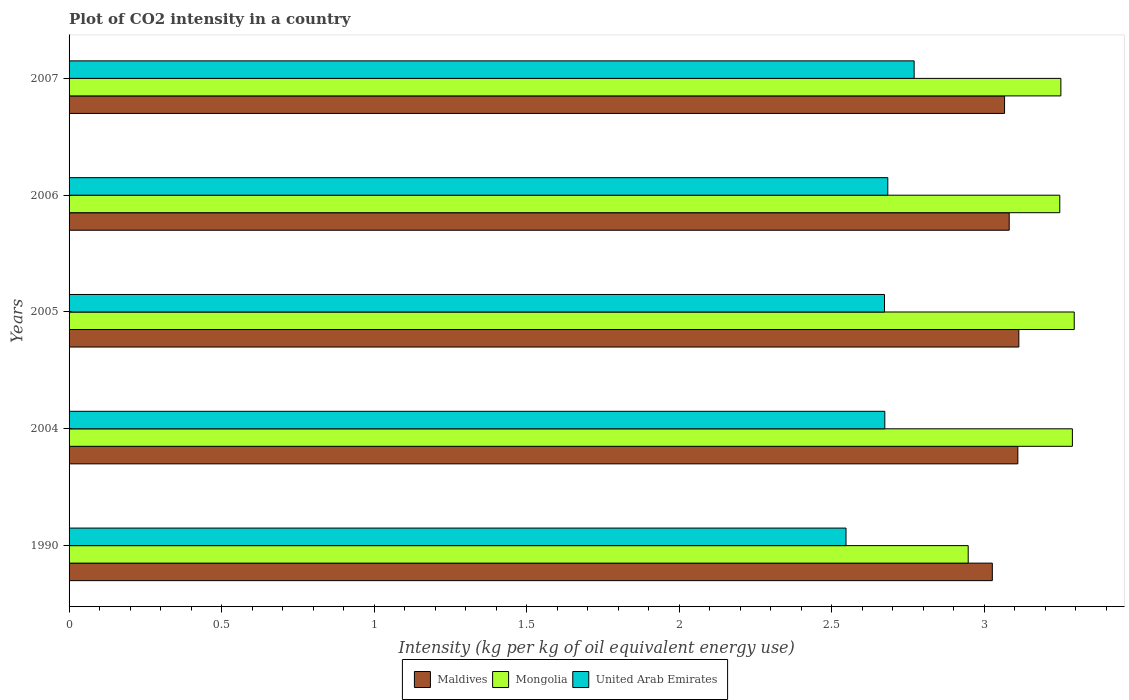Are the number of bars per tick equal to the number of legend labels?
Keep it short and to the point. Yes. Are the number of bars on each tick of the Y-axis equal?
Make the answer very short. Yes. How many bars are there on the 4th tick from the top?
Your answer should be very brief. 3. How many bars are there on the 1st tick from the bottom?
Provide a short and direct response. 3. What is the label of the 2nd group of bars from the top?
Your response must be concise. 2006. What is the CO2 intensity in in Mongolia in 2007?
Keep it short and to the point. 3.25. Across all years, what is the maximum CO2 intensity in in Maldives?
Provide a short and direct response. 3.11. Across all years, what is the minimum CO2 intensity in in Mongolia?
Give a very brief answer. 2.95. What is the total CO2 intensity in in Mongolia in the graph?
Give a very brief answer. 16.03. What is the difference between the CO2 intensity in in Mongolia in 2004 and that in 2007?
Provide a short and direct response. 0.04. What is the difference between the CO2 intensity in in Mongolia in 1990 and the CO2 intensity in in United Arab Emirates in 2006?
Offer a terse response. 0.26. What is the average CO2 intensity in in Mongolia per year?
Keep it short and to the point. 3.21. In the year 2005, what is the difference between the CO2 intensity in in Mongolia and CO2 intensity in in Maldives?
Provide a short and direct response. 0.18. In how many years, is the CO2 intensity in in Mongolia greater than 0.30000000000000004 kg?
Ensure brevity in your answer.  5. What is the ratio of the CO2 intensity in in United Arab Emirates in 1990 to that in 2005?
Offer a terse response. 0.95. Is the CO2 intensity in in Mongolia in 2004 less than that in 2005?
Provide a short and direct response. Yes. What is the difference between the highest and the second highest CO2 intensity in in Mongolia?
Make the answer very short. 0.01. What is the difference between the highest and the lowest CO2 intensity in in United Arab Emirates?
Give a very brief answer. 0.22. In how many years, is the CO2 intensity in in Maldives greater than the average CO2 intensity in in Maldives taken over all years?
Offer a very short reply. 3. What does the 2nd bar from the top in 2004 represents?
Give a very brief answer. Mongolia. What does the 2nd bar from the bottom in 1990 represents?
Give a very brief answer. Mongolia. How many bars are there?
Give a very brief answer. 15. What is the difference between two consecutive major ticks on the X-axis?
Provide a succinct answer. 0.5. Does the graph contain any zero values?
Offer a very short reply. No. Where does the legend appear in the graph?
Offer a very short reply. Bottom center. How are the legend labels stacked?
Provide a short and direct response. Horizontal. What is the title of the graph?
Provide a short and direct response. Plot of CO2 intensity in a country. Does "Angola" appear as one of the legend labels in the graph?
Your answer should be very brief. No. What is the label or title of the X-axis?
Provide a short and direct response. Intensity (kg per kg of oil equivalent energy use). What is the Intensity (kg per kg of oil equivalent energy use) in Maldives in 1990?
Give a very brief answer. 3.03. What is the Intensity (kg per kg of oil equivalent energy use) of Mongolia in 1990?
Ensure brevity in your answer.  2.95. What is the Intensity (kg per kg of oil equivalent energy use) in United Arab Emirates in 1990?
Provide a succinct answer. 2.55. What is the Intensity (kg per kg of oil equivalent energy use) in Maldives in 2004?
Give a very brief answer. 3.11. What is the Intensity (kg per kg of oil equivalent energy use) of Mongolia in 2004?
Make the answer very short. 3.29. What is the Intensity (kg per kg of oil equivalent energy use) in United Arab Emirates in 2004?
Offer a very short reply. 2.67. What is the Intensity (kg per kg of oil equivalent energy use) in Maldives in 2005?
Offer a very short reply. 3.11. What is the Intensity (kg per kg of oil equivalent energy use) of Mongolia in 2005?
Keep it short and to the point. 3.29. What is the Intensity (kg per kg of oil equivalent energy use) of United Arab Emirates in 2005?
Make the answer very short. 2.67. What is the Intensity (kg per kg of oil equivalent energy use) of Maldives in 2006?
Give a very brief answer. 3.08. What is the Intensity (kg per kg of oil equivalent energy use) in Mongolia in 2006?
Your answer should be very brief. 3.25. What is the Intensity (kg per kg of oil equivalent energy use) in United Arab Emirates in 2006?
Your answer should be very brief. 2.68. What is the Intensity (kg per kg of oil equivalent energy use) in Maldives in 2007?
Keep it short and to the point. 3.07. What is the Intensity (kg per kg of oil equivalent energy use) of Mongolia in 2007?
Give a very brief answer. 3.25. What is the Intensity (kg per kg of oil equivalent energy use) in United Arab Emirates in 2007?
Your answer should be very brief. 2.77. Across all years, what is the maximum Intensity (kg per kg of oil equivalent energy use) of Maldives?
Your answer should be very brief. 3.11. Across all years, what is the maximum Intensity (kg per kg of oil equivalent energy use) of Mongolia?
Provide a short and direct response. 3.29. Across all years, what is the maximum Intensity (kg per kg of oil equivalent energy use) of United Arab Emirates?
Your answer should be very brief. 2.77. Across all years, what is the minimum Intensity (kg per kg of oil equivalent energy use) of Maldives?
Provide a succinct answer. 3.03. Across all years, what is the minimum Intensity (kg per kg of oil equivalent energy use) of Mongolia?
Ensure brevity in your answer.  2.95. Across all years, what is the minimum Intensity (kg per kg of oil equivalent energy use) of United Arab Emirates?
Provide a succinct answer. 2.55. What is the total Intensity (kg per kg of oil equivalent energy use) of Maldives in the graph?
Provide a short and direct response. 15.4. What is the total Intensity (kg per kg of oil equivalent energy use) of Mongolia in the graph?
Your answer should be very brief. 16.03. What is the total Intensity (kg per kg of oil equivalent energy use) of United Arab Emirates in the graph?
Ensure brevity in your answer.  13.35. What is the difference between the Intensity (kg per kg of oil equivalent energy use) in Maldives in 1990 and that in 2004?
Your response must be concise. -0.08. What is the difference between the Intensity (kg per kg of oil equivalent energy use) of Mongolia in 1990 and that in 2004?
Keep it short and to the point. -0.34. What is the difference between the Intensity (kg per kg of oil equivalent energy use) of United Arab Emirates in 1990 and that in 2004?
Ensure brevity in your answer.  -0.13. What is the difference between the Intensity (kg per kg of oil equivalent energy use) in Maldives in 1990 and that in 2005?
Your answer should be very brief. -0.09. What is the difference between the Intensity (kg per kg of oil equivalent energy use) in Mongolia in 1990 and that in 2005?
Provide a short and direct response. -0.35. What is the difference between the Intensity (kg per kg of oil equivalent energy use) of United Arab Emirates in 1990 and that in 2005?
Offer a terse response. -0.13. What is the difference between the Intensity (kg per kg of oil equivalent energy use) in Maldives in 1990 and that in 2006?
Ensure brevity in your answer.  -0.06. What is the difference between the Intensity (kg per kg of oil equivalent energy use) of Mongolia in 1990 and that in 2006?
Your response must be concise. -0.3. What is the difference between the Intensity (kg per kg of oil equivalent energy use) in United Arab Emirates in 1990 and that in 2006?
Your response must be concise. -0.14. What is the difference between the Intensity (kg per kg of oil equivalent energy use) of Maldives in 1990 and that in 2007?
Offer a very short reply. -0.04. What is the difference between the Intensity (kg per kg of oil equivalent energy use) in Mongolia in 1990 and that in 2007?
Offer a very short reply. -0.3. What is the difference between the Intensity (kg per kg of oil equivalent energy use) of United Arab Emirates in 1990 and that in 2007?
Your answer should be compact. -0.22. What is the difference between the Intensity (kg per kg of oil equivalent energy use) of Maldives in 2004 and that in 2005?
Provide a short and direct response. -0. What is the difference between the Intensity (kg per kg of oil equivalent energy use) in Mongolia in 2004 and that in 2005?
Make the answer very short. -0.01. What is the difference between the Intensity (kg per kg of oil equivalent energy use) in Maldives in 2004 and that in 2006?
Make the answer very short. 0.03. What is the difference between the Intensity (kg per kg of oil equivalent energy use) of Mongolia in 2004 and that in 2006?
Offer a very short reply. 0.04. What is the difference between the Intensity (kg per kg of oil equivalent energy use) of United Arab Emirates in 2004 and that in 2006?
Ensure brevity in your answer.  -0.01. What is the difference between the Intensity (kg per kg of oil equivalent energy use) of Maldives in 2004 and that in 2007?
Make the answer very short. 0.04. What is the difference between the Intensity (kg per kg of oil equivalent energy use) of Mongolia in 2004 and that in 2007?
Offer a very short reply. 0.04. What is the difference between the Intensity (kg per kg of oil equivalent energy use) in United Arab Emirates in 2004 and that in 2007?
Your answer should be compact. -0.1. What is the difference between the Intensity (kg per kg of oil equivalent energy use) of Maldives in 2005 and that in 2006?
Provide a short and direct response. 0.03. What is the difference between the Intensity (kg per kg of oil equivalent energy use) in Mongolia in 2005 and that in 2006?
Keep it short and to the point. 0.05. What is the difference between the Intensity (kg per kg of oil equivalent energy use) in United Arab Emirates in 2005 and that in 2006?
Provide a short and direct response. -0.01. What is the difference between the Intensity (kg per kg of oil equivalent energy use) of Maldives in 2005 and that in 2007?
Give a very brief answer. 0.05. What is the difference between the Intensity (kg per kg of oil equivalent energy use) in Mongolia in 2005 and that in 2007?
Your answer should be compact. 0.04. What is the difference between the Intensity (kg per kg of oil equivalent energy use) in United Arab Emirates in 2005 and that in 2007?
Your answer should be very brief. -0.1. What is the difference between the Intensity (kg per kg of oil equivalent energy use) of Maldives in 2006 and that in 2007?
Make the answer very short. 0.02. What is the difference between the Intensity (kg per kg of oil equivalent energy use) of Mongolia in 2006 and that in 2007?
Offer a terse response. -0. What is the difference between the Intensity (kg per kg of oil equivalent energy use) of United Arab Emirates in 2006 and that in 2007?
Offer a very short reply. -0.09. What is the difference between the Intensity (kg per kg of oil equivalent energy use) in Maldives in 1990 and the Intensity (kg per kg of oil equivalent energy use) in Mongolia in 2004?
Offer a terse response. -0.26. What is the difference between the Intensity (kg per kg of oil equivalent energy use) of Maldives in 1990 and the Intensity (kg per kg of oil equivalent energy use) of United Arab Emirates in 2004?
Your response must be concise. 0.35. What is the difference between the Intensity (kg per kg of oil equivalent energy use) in Mongolia in 1990 and the Intensity (kg per kg of oil equivalent energy use) in United Arab Emirates in 2004?
Your answer should be very brief. 0.27. What is the difference between the Intensity (kg per kg of oil equivalent energy use) of Maldives in 1990 and the Intensity (kg per kg of oil equivalent energy use) of Mongolia in 2005?
Your answer should be very brief. -0.27. What is the difference between the Intensity (kg per kg of oil equivalent energy use) in Maldives in 1990 and the Intensity (kg per kg of oil equivalent energy use) in United Arab Emirates in 2005?
Offer a terse response. 0.35. What is the difference between the Intensity (kg per kg of oil equivalent energy use) of Mongolia in 1990 and the Intensity (kg per kg of oil equivalent energy use) of United Arab Emirates in 2005?
Offer a terse response. 0.27. What is the difference between the Intensity (kg per kg of oil equivalent energy use) of Maldives in 1990 and the Intensity (kg per kg of oil equivalent energy use) of Mongolia in 2006?
Your response must be concise. -0.22. What is the difference between the Intensity (kg per kg of oil equivalent energy use) in Maldives in 1990 and the Intensity (kg per kg of oil equivalent energy use) in United Arab Emirates in 2006?
Your answer should be compact. 0.34. What is the difference between the Intensity (kg per kg of oil equivalent energy use) of Mongolia in 1990 and the Intensity (kg per kg of oil equivalent energy use) of United Arab Emirates in 2006?
Your response must be concise. 0.26. What is the difference between the Intensity (kg per kg of oil equivalent energy use) in Maldives in 1990 and the Intensity (kg per kg of oil equivalent energy use) in Mongolia in 2007?
Offer a very short reply. -0.22. What is the difference between the Intensity (kg per kg of oil equivalent energy use) in Maldives in 1990 and the Intensity (kg per kg of oil equivalent energy use) in United Arab Emirates in 2007?
Your answer should be very brief. 0.26. What is the difference between the Intensity (kg per kg of oil equivalent energy use) of Mongolia in 1990 and the Intensity (kg per kg of oil equivalent energy use) of United Arab Emirates in 2007?
Your response must be concise. 0.18. What is the difference between the Intensity (kg per kg of oil equivalent energy use) in Maldives in 2004 and the Intensity (kg per kg of oil equivalent energy use) in Mongolia in 2005?
Your answer should be compact. -0.18. What is the difference between the Intensity (kg per kg of oil equivalent energy use) in Maldives in 2004 and the Intensity (kg per kg of oil equivalent energy use) in United Arab Emirates in 2005?
Your answer should be compact. 0.44. What is the difference between the Intensity (kg per kg of oil equivalent energy use) of Mongolia in 2004 and the Intensity (kg per kg of oil equivalent energy use) of United Arab Emirates in 2005?
Ensure brevity in your answer.  0.62. What is the difference between the Intensity (kg per kg of oil equivalent energy use) in Maldives in 2004 and the Intensity (kg per kg of oil equivalent energy use) in Mongolia in 2006?
Provide a succinct answer. -0.14. What is the difference between the Intensity (kg per kg of oil equivalent energy use) in Maldives in 2004 and the Intensity (kg per kg of oil equivalent energy use) in United Arab Emirates in 2006?
Give a very brief answer. 0.43. What is the difference between the Intensity (kg per kg of oil equivalent energy use) in Mongolia in 2004 and the Intensity (kg per kg of oil equivalent energy use) in United Arab Emirates in 2006?
Offer a terse response. 0.6. What is the difference between the Intensity (kg per kg of oil equivalent energy use) of Maldives in 2004 and the Intensity (kg per kg of oil equivalent energy use) of Mongolia in 2007?
Your answer should be very brief. -0.14. What is the difference between the Intensity (kg per kg of oil equivalent energy use) of Maldives in 2004 and the Intensity (kg per kg of oil equivalent energy use) of United Arab Emirates in 2007?
Provide a short and direct response. 0.34. What is the difference between the Intensity (kg per kg of oil equivalent energy use) in Mongolia in 2004 and the Intensity (kg per kg of oil equivalent energy use) in United Arab Emirates in 2007?
Provide a succinct answer. 0.52. What is the difference between the Intensity (kg per kg of oil equivalent energy use) in Maldives in 2005 and the Intensity (kg per kg of oil equivalent energy use) in Mongolia in 2006?
Keep it short and to the point. -0.13. What is the difference between the Intensity (kg per kg of oil equivalent energy use) of Maldives in 2005 and the Intensity (kg per kg of oil equivalent energy use) of United Arab Emirates in 2006?
Your answer should be very brief. 0.43. What is the difference between the Intensity (kg per kg of oil equivalent energy use) in Mongolia in 2005 and the Intensity (kg per kg of oil equivalent energy use) in United Arab Emirates in 2006?
Your answer should be very brief. 0.61. What is the difference between the Intensity (kg per kg of oil equivalent energy use) of Maldives in 2005 and the Intensity (kg per kg of oil equivalent energy use) of Mongolia in 2007?
Offer a terse response. -0.14. What is the difference between the Intensity (kg per kg of oil equivalent energy use) of Maldives in 2005 and the Intensity (kg per kg of oil equivalent energy use) of United Arab Emirates in 2007?
Your answer should be very brief. 0.34. What is the difference between the Intensity (kg per kg of oil equivalent energy use) in Mongolia in 2005 and the Intensity (kg per kg of oil equivalent energy use) in United Arab Emirates in 2007?
Your answer should be very brief. 0.52. What is the difference between the Intensity (kg per kg of oil equivalent energy use) of Maldives in 2006 and the Intensity (kg per kg of oil equivalent energy use) of Mongolia in 2007?
Ensure brevity in your answer.  -0.17. What is the difference between the Intensity (kg per kg of oil equivalent energy use) of Maldives in 2006 and the Intensity (kg per kg of oil equivalent energy use) of United Arab Emirates in 2007?
Make the answer very short. 0.31. What is the difference between the Intensity (kg per kg of oil equivalent energy use) in Mongolia in 2006 and the Intensity (kg per kg of oil equivalent energy use) in United Arab Emirates in 2007?
Provide a short and direct response. 0.48. What is the average Intensity (kg per kg of oil equivalent energy use) in Maldives per year?
Offer a terse response. 3.08. What is the average Intensity (kg per kg of oil equivalent energy use) in Mongolia per year?
Make the answer very short. 3.21. What is the average Intensity (kg per kg of oil equivalent energy use) of United Arab Emirates per year?
Give a very brief answer. 2.67. In the year 1990, what is the difference between the Intensity (kg per kg of oil equivalent energy use) of Maldives and Intensity (kg per kg of oil equivalent energy use) of Mongolia?
Your response must be concise. 0.08. In the year 1990, what is the difference between the Intensity (kg per kg of oil equivalent energy use) in Maldives and Intensity (kg per kg of oil equivalent energy use) in United Arab Emirates?
Keep it short and to the point. 0.48. In the year 1990, what is the difference between the Intensity (kg per kg of oil equivalent energy use) of Mongolia and Intensity (kg per kg of oil equivalent energy use) of United Arab Emirates?
Provide a succinct answer. 0.4. In the year 2004, what is the difference between the Intensity (kg per kg of oil equivalent energy use) of Maldives and Intensity (kg per kg of oil equivalent energy use) of Mongolia?
Provide a succinct answer. -0.18. In the year 2004, what is the difference between the Intensity (kg per kg of oil equivalent energy use) of Maldives and Intensity (kg per kg of oil equivalent energy use) of United Arab Emirates?
Give a very brief answer. 0.44. In the year 2004, what is the difference between the Intensity (kg per kg of oil equivalent energy use) in Mongolia and Intensity (kg per kg of oil equivalent energy use) in United Arab Emirates?
Provide a succinct answer. 0.61. In the year 2005, what is the difference between the Intensity (kg per kg of oil equivalent energy use) in Maldives and Intensity (kg per kg of oil equivalent energy use) in Mongolia?
Ensure brevity in your answer.  -0.18. In the year 2005, what is the difference between the Intensity (kg per kg of oil equivalent energy use) of Maldives and Intensity (kg per kg of oil equivalent energy use) of United Arab Emirates?
Your response must be concise. 0.44. In the year 2005, what is the difference between the Intensity (kg per kg of oil equivalent energy use) of Mongolia and Intensity (kg per kg of oil equivalent energy use) of United Arab Emirates?
Provide a short and direct response. 0.62. In the year 2006, what is the difference between the Intensity (kg per kg of oil equivalent energy use) in Maldives and Intensity (kg per kg of oil equivalent energy use) in Mongolia?
Your response must be concise. -0.17. In the year 2006, what is the difference between the Intensity (kg per kg of oil equivalent energy use) in Maldives and Intensity (kg per kg of oil equivalent energy use) in United Arab Emirates?
Offer a very short reply. 0.4. In the year 2006, what is the difference between the Intensity (kg per kg of oil equivalent energy use) in Mongolia and Intensity (kg per kg of oil equivalent energy use) in United Arab Emirates?
Your answer should be compact. 0.56. In the year 2007, what is the difference between the Intensity (kg per kg of oil equivalent energy use) of Maldives and Intensity (kg per kg of oil equivalent energy use) of Mongolia?
Give a very brief answer. -0.18. In the year 2007, what is the difference between the Intensity (kg per kg of oil equivalent energy use) of Maldives and Intensity (kg per kg of oil equivalent energy use) of United Arab Emirates?
Offer a terse response. 0.3. In the year 2007, what is the difference between the Intensity (kg per kg of oil equivalent energy use) of Mongolia and Intensity (kg per kg of oil equivalent energy use) of United Arab Emirates?
Give a very brief answer. 0.48. What is the ratio of the Intensity (kg per kg of oil equivalent energy use) in Maldives in 1990 to that in 2004?
Ensure brevity in your answer.  0.97. What is the ratio of the Intensity (kg per kg of oil equivalent energy use) in Mongolia in 1990 to that in 2004?
Ensure brevity in your answer.  0.9. What is the ratio of the Intensity (kg per kg of oil equivalent energy use) of United Arab Emirates in 1990 to that in 2004?
Make the answer very short. 0.95. What is the ratio of the Intensity (kg per kg of oil equivalent energy use) in Maldives in 1990 to that in 2005?
Make the answer very short. 0.97. What is the ratio of the Intensity (kg per kg of oil equivalent energy use) of Mongolia in 1990 to that in 2005?
Your answer should be compact. 0.89. What is the ratio of the Intensity (kg per kg of oil equivalent energy use) of United Arab Emirates in 1990 to that in 2005?
Your response must be concise. 0.95. What is the ratio of the Intensity (kg per kg of oil equivalent energy use) of Maldives in 1990 to that in 2006?
Provide a short and direct response. 0.98. What is the ratio of the Intensity (kg per kg of oil equivalent energy use) of Mongolia in 1990 to that in 2006?
Your answer should be compact. 0.91. What is the ratio of the Intensity (kg per kg of oil equivalent energy use) of United Arab Emirates in 1990 to that in 2006?
Make the answer very short. 0.95. What is the ratio of the Intensity (kg per kg of oil equivalent energy use) of Maldives in 1990 to that in 2007?
Give a very brief answer. 0.99. What is the ratio of the Intensity (kg per kg of oil equivalent energy use) in Mongolia in 1990 to that in 2007?
Give a very brief answer. 0.91. What is the ratio of the Intensity (kg per kg of oil equivalent energy use) of United Arab Emirates in 1990 to that in 2007?
Ensure brevity in your answer.  0.92. What is the ratio of the Intensity (kg per kg of oil equivalent energy use) in Maldives in 2004 to that in 2006?
Give a very brief answer. 1.01. What is the ratio of the Intensity (kg per kg of oil equivalent energy use) of Mongolia in 2004 to that in 2006?
Your answer should be very brief. 1.01. What is the ratio of the Intensity (kg per kg of oil equivalent energy use) of United Arab Emirates in 2004 to that in 2006?
Make the answer very short. 1. What is the ratio of the Intensity (kg per kg of oil equivalent energy use) of Maldives in 2004 to that in 2007?
Ensure brevity in your answer.  1.01. What is the ratio of the Intensity (kg per kg of oil equivalent energy use) in Mongolia in 2004 to that in 2007?
Your response must be concise. 1.01. What is the ratio of the Intensity (kg per kg of oil equivalent energy use) of United Arab Emirates in 2004 to that in 2007?
Offer a very short reply. 0.97. What is the ratio of the Intensity (kg per kg of oil equivalent energy use) of Maldives in 2005 to that in 2006?
Provide a short and direct response. 1.01. What is the ratio of the Intensity (kg per kg of oil equivalent energy use) in Mongolia in 2005 to that in 2006?
Offer a very short reply. 1.01. What is the ratio of the Intensity (kg per kg of oil equivalent energy use) of United Arab Emirates in 2005 to that in 2006?
Provide a short and direct response. 1. What is the ratio of the Intensity (kg per kg of oil equivalent energy use) in Maldives in 2005 to that in 2007?
Offer a terse response. 1.02. What is the ratio of the Intensity (kg per kg of oil equivalent energy use) in Mongolia in 2005 to that in 2007?
Provide a short and direct response. 1.01. What is the ratio of the Intensity (kg per kg of oil equivalent energy use) of United Arab Emirates in 2005 to that in 2007?
Provide a succinct answer. 0.96. What is the ratio of the Intensity (kg per kg of oil equivalent energy use) of Maldives in 2006 to that in 2007?
Keep it short and to the point. 1. What is the ratio of the Intensity (kg per kg of oil equivalent energy use) in Mongolia in 2006 to that in 2007?
Provide a short and direct response. 1. What is the ratio of the Intensity (kg per kg of oil equivalent energy use) of United Arab Emirates in 2006 to that in 2007?
Your answer should be very brief. 0.97. What is the difference between the highest and the second highest Intensity (kg per kg of oil equivalent energy use) of Maldives?
Make the answer very short. 0. What is the difference between the highest and the second highest Intensity (kg per kg of oil equivalent energy use) of Mongolia?
Give a very brief answer. 0.01. What is the difference between the highest and the second highest Intensity (kg per kg of oil equivalent energy use) in United Arab Emirates?
Provide a short and direct response. 0.09. What is the difference between the highest and the lowest Intensity (kg per kg of oil equivalent energy use) of Maldives?
Give a very brief answer. 0.09. What is the difference between the highest and the lowest Intensity (kg per kg of oil equivalent energy use) of Mongolia?
Offer a terse response. 0.35. What is the difference between the highest and the lowest Intensity (kg per kg of oil equivalent energy use) in United Arab Emirates?
Offer a very short reply. 0.22. 